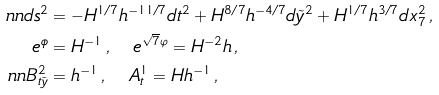<formula> <loc_0><loc_0><loc_500><loc_500>\ n n d s ^ { 2 } & = - H ^ { 1 / 7 } h ^ { - 1 1 / 7 } d t ^ { 2 } + H ^ { 8 / 7 } h ^ { - 4 / 7 } d \tilde { y } ^ { 2 } + H ^ { 1 / 7 } h ^ { 3 / 7 } d x _ { 7 } ^ { 2 } \, , \\ e ^ { \phi } & = H ^ { - 1 } \, , \quad e ^ { \sqrt { 7 } \varphi } = H ^ { - 2 } h \, , \\ \ n n B ^ { 2 } _ { t \tilde { y } } & = h ^ { - 1 } \, , \quad A ^ { 1 } _ { t } = H h ^ { - 1 } \, ,</formula> 